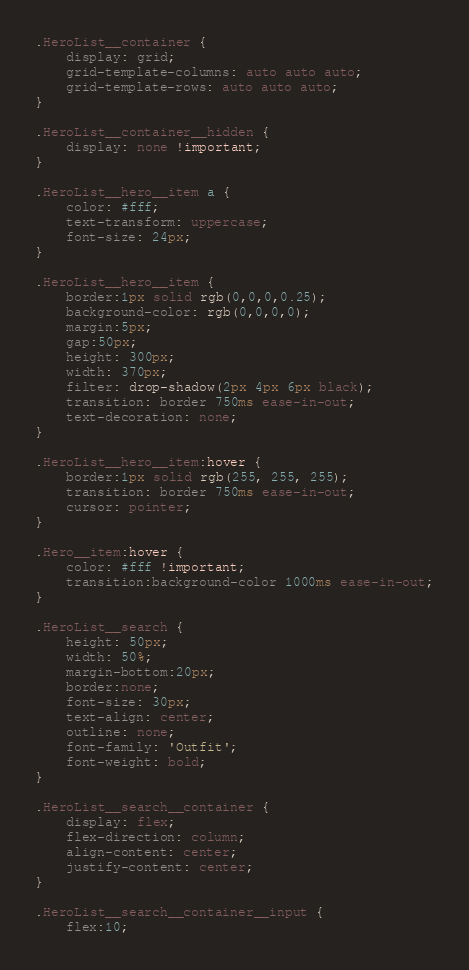Convert code to text. <code><loc_0><loc_0><loc_500><loc_500><_CSS_>.HeroList__container {
    display: grid;
    grid-template-columns: auto auto auto;
    grid-template-rows: auto auto auto;
}

.HeroList__container__hidden {
    display: none !important;
}

.HeroList__hero__item a {
    color: #fff;
    text-transform: uppercase;
    font-size: 24px;
}

.HeroList__hero__item {
    border:1px solid rgb(0,0,0,0.25);
    background-color: rgb(0,0,0,0);
    margin:5px;
    gap:50px;
    height: 300px;
    width: 370px;
    filter: drop-shadow(2px 4px 6px black);
    transition: border 750ms ease-in-out;
    text-decoration: none;
}

.HeroList__hero__item:hover {
    border:1px solid rgb(255, 255, 255);
    transition: border 750ms ease-in-out;
    cursor: pointer;
}

.Hero__item:hover {
    color: #fff !important;
    transition:background-color 1000ms ease-in-out;
}

.HeroList__search {
    height: 50px;
    width: 50%;
    margin-bottom:20px;
    border:none;
    font-size: 30px;
    text-align: center;
    outline: none;
    font-family: 'Outfit';
    font-weight: bold;
}

.HeroList__search__container {
    display: flex;
    flex-direction: column;
    align-content: center;
    justify-content: center;
}

.HeroList__search__container__input {
    flex:10;</code> 